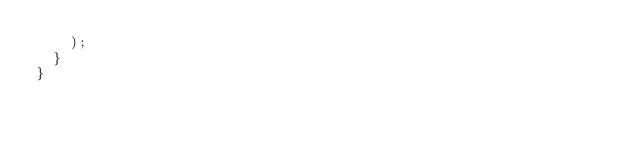<code> <loc_0><loc_0><loc_500><loc_500><_TypeScript_>    );
  }
}
</code> 